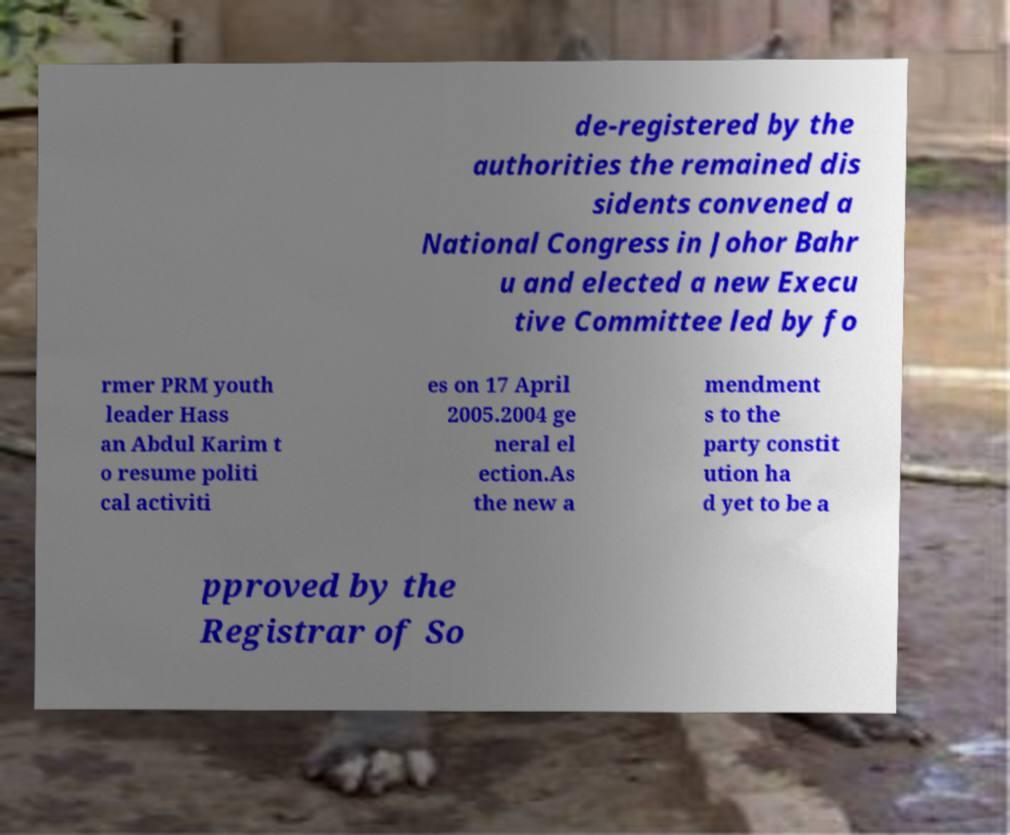There's text embedded in this image that I need extracted. Can you transcribe it verbatim? de-registered by the authorities the remained dis sidents convened a National Congress in Johor Bahr u and elected a new Execu tive Committee led by fo rmer PRM youth leader Hass an Abdul Karim t o resume politi cal activiti es on 17 April 2005.2004 ge neral el ection.As the new a mendment s to the party constit ution ha d yet to be a pproved by the Registrar of So 